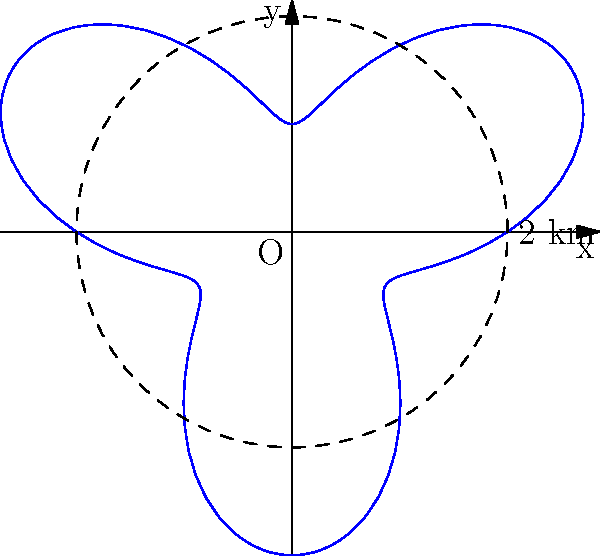In a circular habitat with a radius of 2 km, a genetically modified organism (GMO) has been released at the center. The spread of the GMO follows a unique pattern described by the polar equation $r = 2 + \sin(3\theta)$, where $r$ is in kilometers. What is the maximum distance from the center that the GMO reaches? To find the maximum distance the GMO reaches from the center, we need to follow these steps:

1) The spread of the GMO is described by the polar equation $r = 2 + \sin(3\theta)$.

2) The maximum value of $\sin(3\theta)$ is 1, which occurs when $3\theta = \frac{\pi}{2}, \frac{5\pi}{2}, \frac{9\pi}{2}$, etc.

3) When $\sin(3\theta) = 1$, the equation becomes:
   $r_{max} = 2 + 1 = 3$

4) Therefore, the maximum distance from the center that the GMO reaches is 3 km.

5) This result shows that the GMO has spread beyond the original habitat boundary (which had a radius of 2 km), mimicking the uncontrolled spread of genetically modified organisms often depicted in science fiction scenarios like "Jurassic Park".
Answer: 3 km 